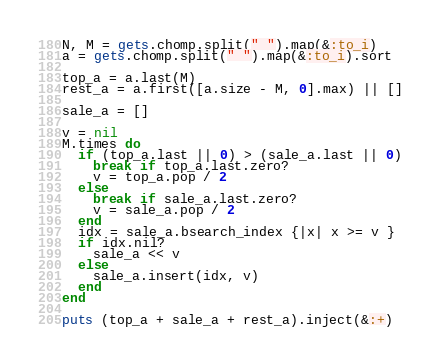Convert code to text. <code><loc_0><loc_0><loc_500><loc_500><_Ruby_>N, M = gets.chomp.split(" ").map(&:to_i)
a = gets.chomp.split(" ").map(&:to_i).sort

top_a = a.last(M)
rest_a = a.first([a.size - M, 0].max) || []

sale_a = []

v = nil
M.times do
  if (top_a.last || 0) > (sale_a.last || 0)
    break if top_a.last.zero?
    v = top_a.pop / 2
  else
    break if sale_a.last.zero?
    v = sale_a.pop / 2
  end
  idx = sale_a.bsearch_index {|x| x >= v }
  if idx.nil?
    sale_a << v
  else
    sale_a.insert(idx, v)
  end
end

puts (top_a + sale_a + rest_a).inject(&:+)
</code> 